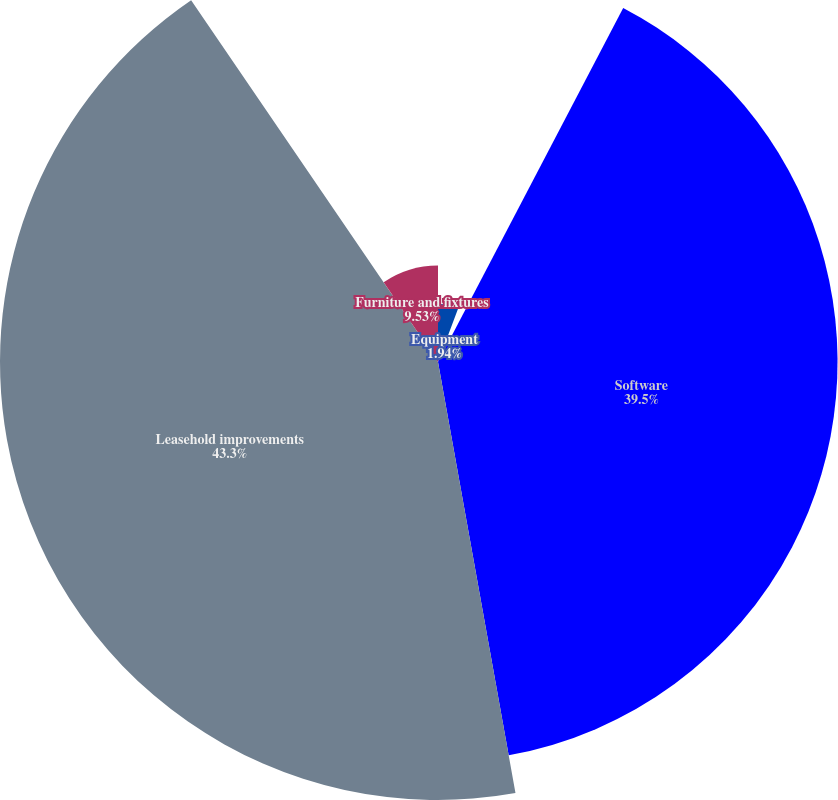<chart> <loc_0><loc_0><loc_500><loc_500><pie_chart><fcel>Building<fcel>Equipment<fcel>Software<fcel>Leasehold improvements<fcel>Furniture and fixtures<nl><fcel>5.73%<fcel>1.94%<fcel>39.5%<fcel>43.3%<fcel>9.53%<nl></chart> 